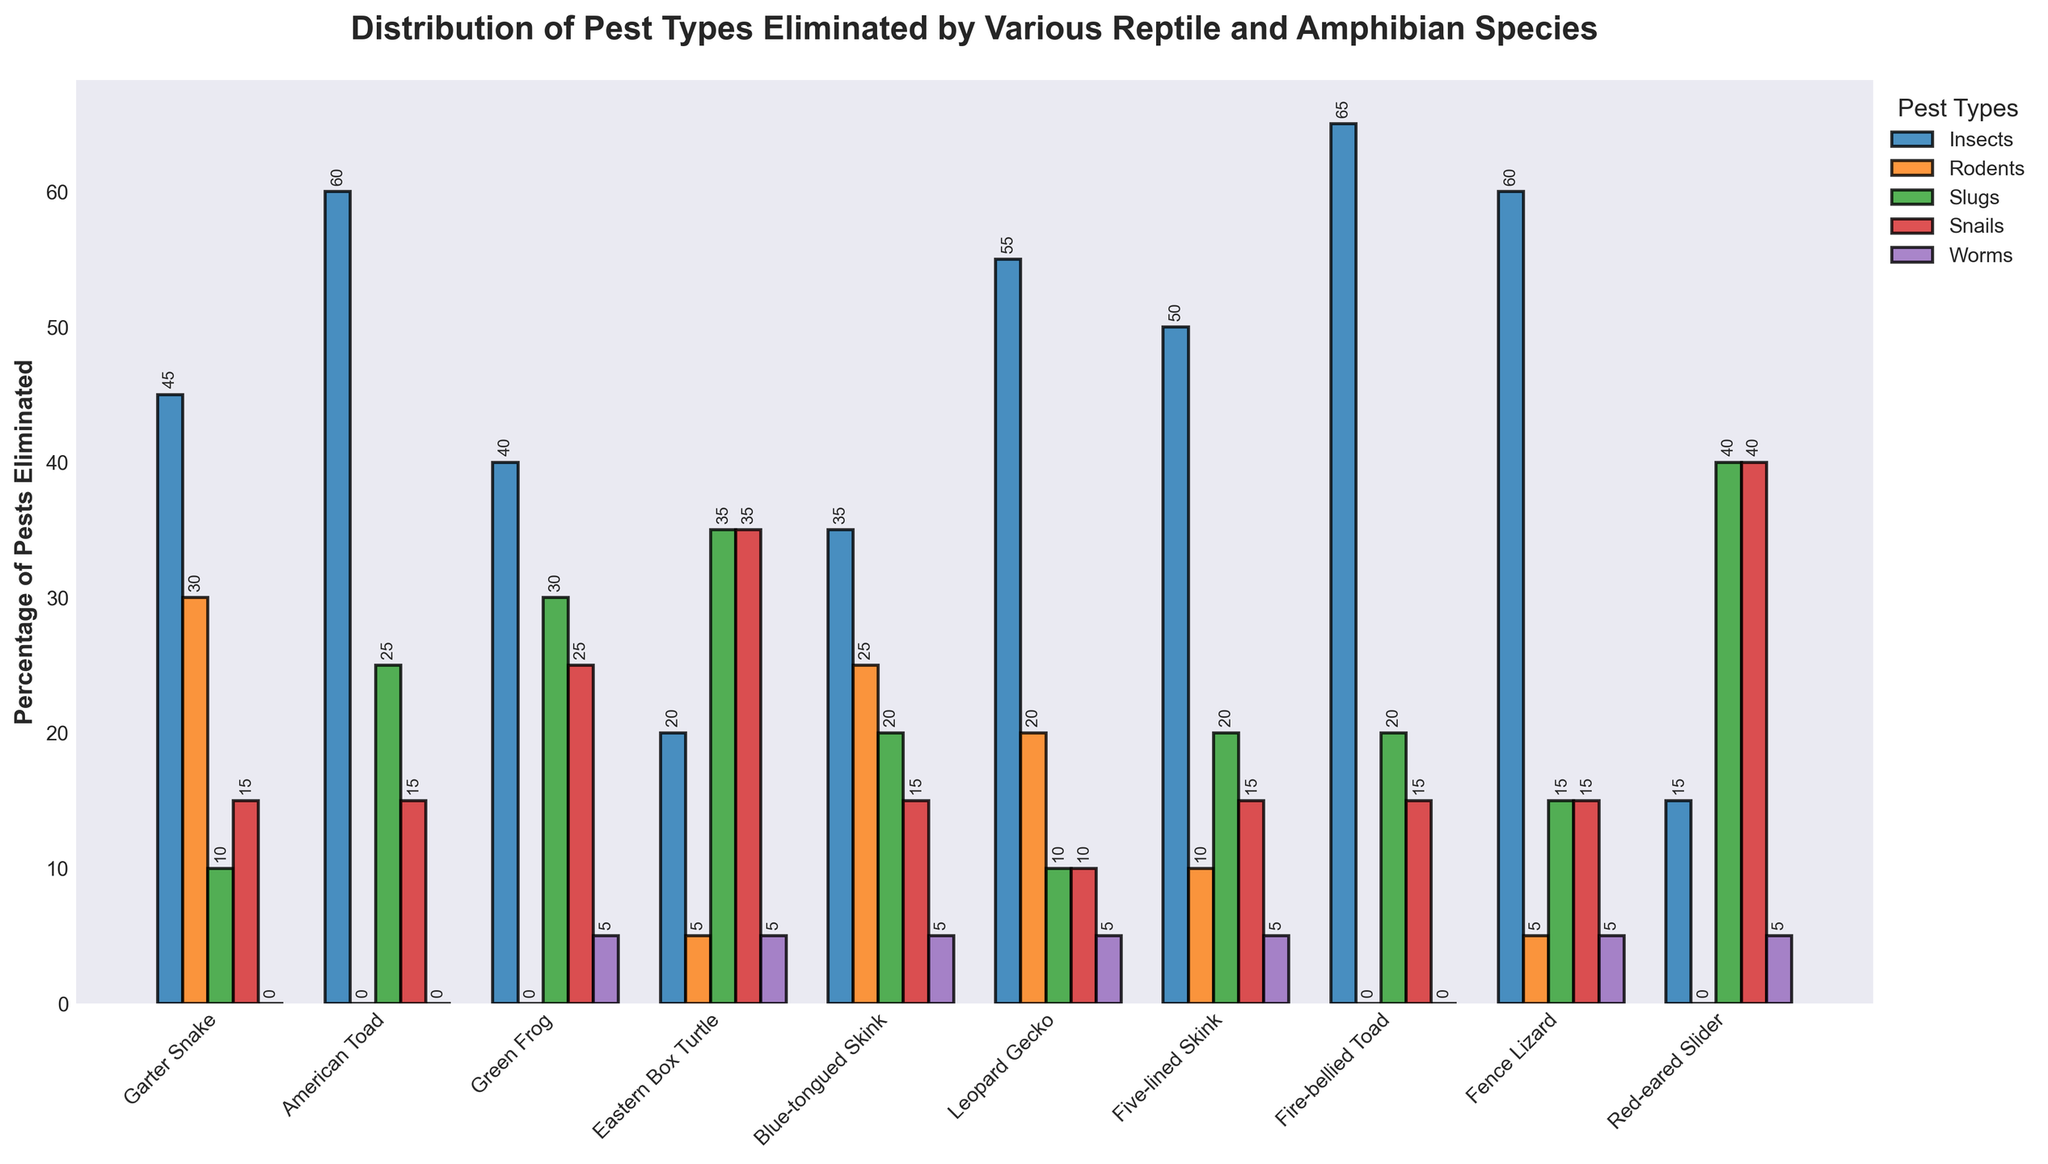What species eliminates the most rodents? To identify this, observe the heights of the bars in the "Rodents" categorical series. The highest bar represents the Garter Snake with 30%.
Answer: Garter Snake Which species is the best at eliminating insects? Look for the species with the tallest bar in the "Insects" category. The Fire-bellied Toad has the highest bar at 65%.
Answer: Fire-bellied Toad How many species eliminate snails more efficiently than rodents? Compare the heights of the bars in the "Snails" and "Rodents" categories for each species. Calculate the count of species where the "Snails" bar is higher than the "Rodents" bar. Those species are: Green Frog, Eastern Box Turtle, Red-eared Slider.
Answer: 3 Which pest type does the Eastern Box Turtle eliminate the least? For the Eastern Box Turtle, compare the heights of the bars in all pest categories. The shortest bar represents "Rodents" at 5%.
Answer: Rodents What is the total percentage of pests eliminated by the Leopard Gecko? Sum the percentages from all pest categories for the Leopard Gecko: 55 (Insects) + 20 (Rodents) + 10 (Slugs) + 10 (Snails) + 5 (Worms) = 100.
Answer: 100 Which species eliminates worms the most? Look for the species with the tallest bar in the "Worms" category. The Green Frog, Eastern Box Turtle, Blue-tongued Skink, Leopard Gecko, Five-lined Skink, Fence Lizard, and Red-eared Slider all have bars at 5%, they all eliminate worms equally.
Answer: Green Frog, Eastern Box Turtle, Blue-tongued Skink, Leopard Gecko, Five-lined Skink, Fence Lizard, Red-eared Slider Which species is equally effective at eliminating both slugs and snails? Identify the species with bars of equal height for both "Slugs" and "Snails" categories. The Eastern Box Turtle eliminates both at 35%.
Answer: Eastern Box Turtle Rank the species in terms of total percentage of slugs eliminated, from highest to lowest. List species based on the heights of their bars in the "Slugs" category: Red-eared Slider (40), Eastern Box Turtle (35), Green Frog (30), Blue-tongued Skink/Fire-bellied Toad/Five-lined Skink (20), American Toad (25), Fence Lizard (15), Garter Snake/Leopard Gecko (10).
Answer: Red-eared Slider, Eastern Box Turtle, Green Frog, Blue-tongued Skink, American Toad, Fire-bellied Toad, Five-lined Skink, Fence Lizard, Garter Snake, Leopard Gecko 